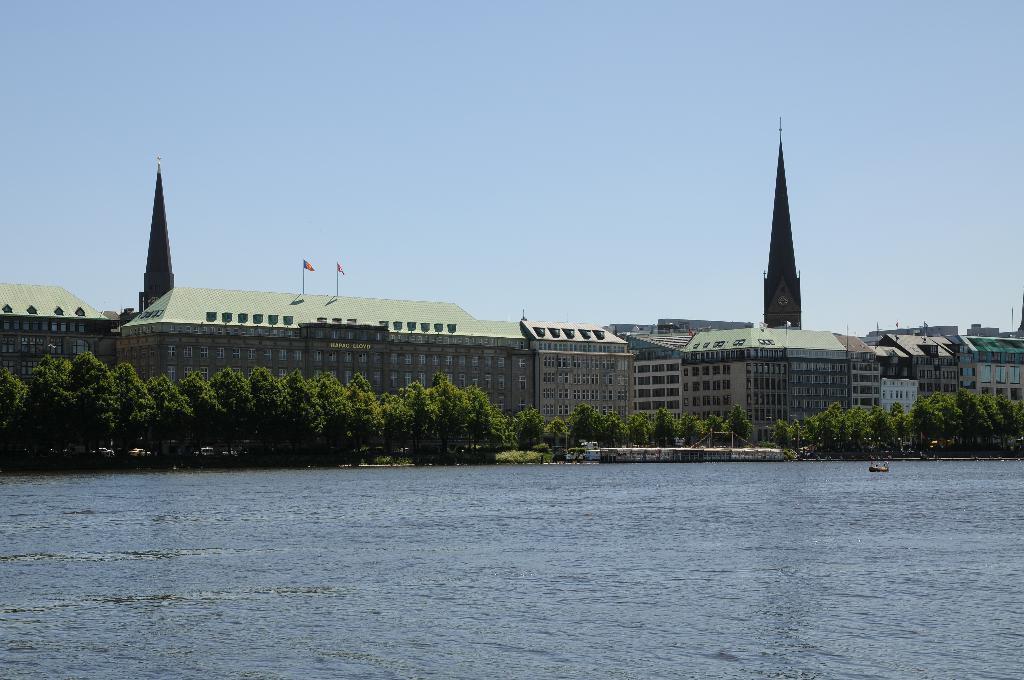Describe this image in one or two sentences. We can see water. In the background we can see trees,buildings,towers,flags and sky 